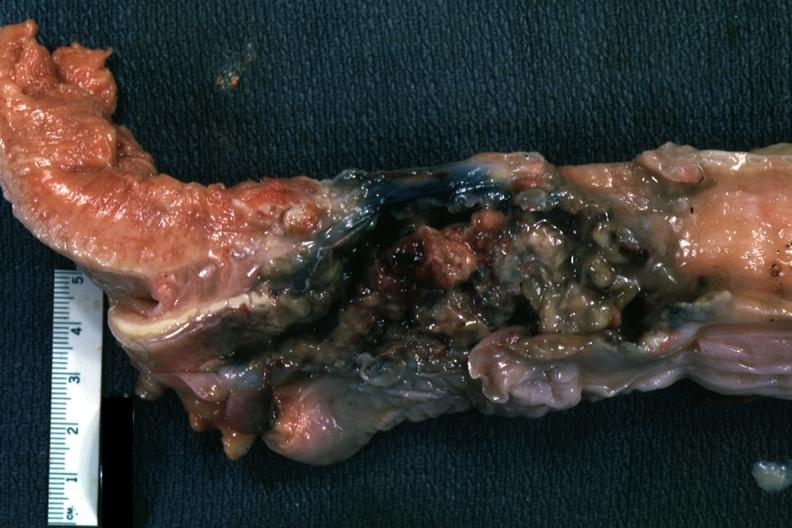s carcinoma present?
Answer the question using a single word or phrase. Yes 